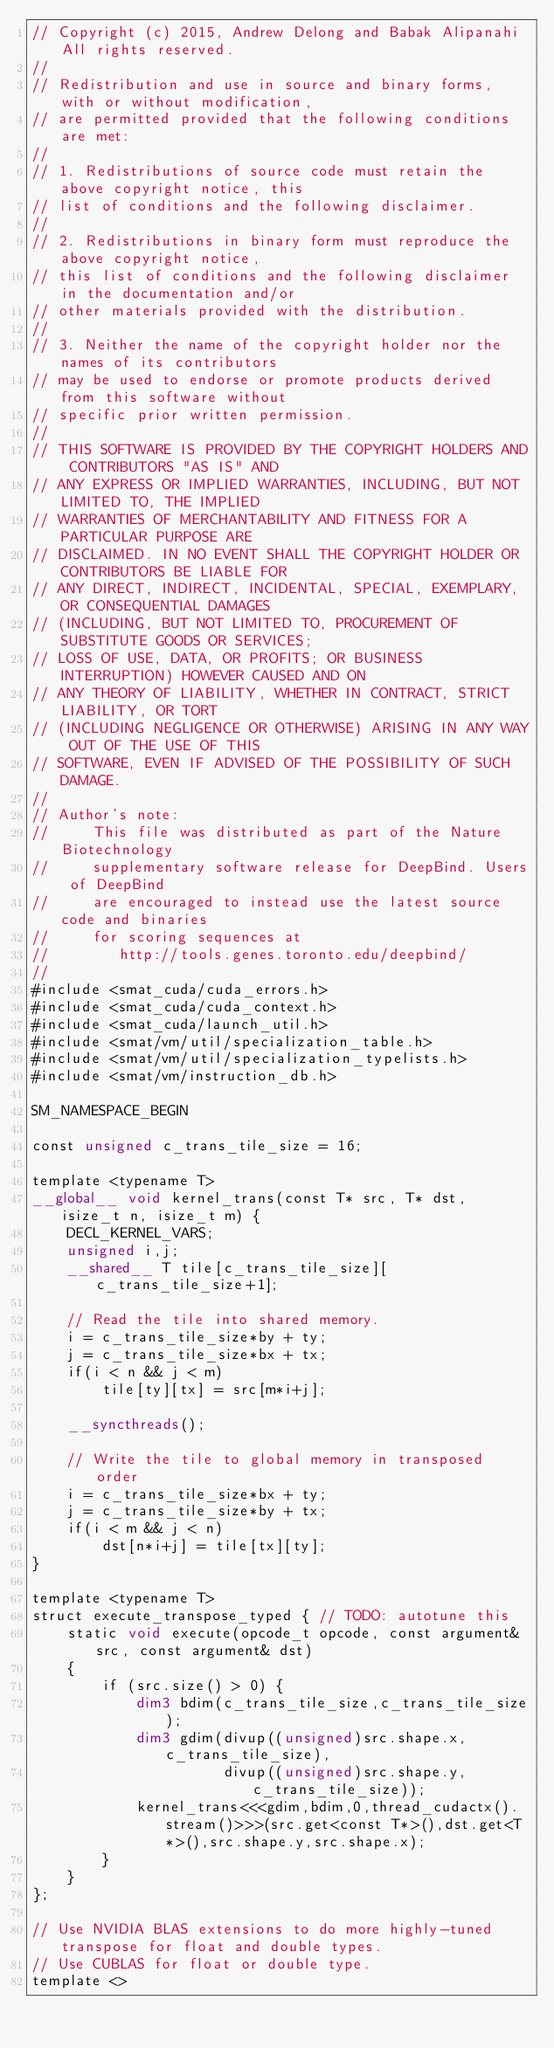Convert code to text. <code><loc_0><loc_0><loc_500><loc_500><_Cuda_>// Copyright (c) 2015, Andrew Delong and Babak Alipanahi All rights reserved.
// 
// Redistribution and use in source and binary forms, with or without modification,
// are permitted provided that the following conditions are met:
// 
// 1. Redistributions of source code must retain the above copyright notice, this
// list of conditions and the following disclaimer.
// 
// 2. Redistributions in binary form must reproduce the above copyright notice,
// this list of conditions and the following disclaimer in the documentation and/or
// other materials provided with the distribution.
// 
// 3. Neither the name of the copyright holder nor the names of its contributors
// may be used to endorse or promote products derived from this software without
// specific prior written permission.
// 
// THIS SOFTWARE IS PROVIDED BY THE COPYRIGHT HOLDERS AND CONTRIBUTORS "AS IS" AND
// ANY EXPRESS OR IMPLIED WARRANTIES, INCLUDING, BUT NOT LIMITED TO, THE IMPLIED
// WARRANTIES OF MERCHANTABILITY AND FITNESS FOR A PARTICULAR PURPOSE ARE
// DISCLAIMED. IN NO EVENT SHALL THE COPYRIGHT HOLDER OR CONTRIBUTORS BE LIABLE FOR
// ANY DIRECT, INDIRECT, INCIDENTAL, SPECIAL, EXEMPLARY, OR CONSEQUENTIAL DAMAGES
// (INCLUDING, BUT NOT LIMITED TO, PROCUREMENT OF SUBSTITUTE GOODS OR SERVICES;
// LOSS OF USE, DATA, OR PROFITS; OR BUSINESS INTERRUPTION) HOWEVER CAUSED AND ON
// ANY THEORY OF LIABILITY, WHETHER IN CONTRACT, STRICT LIABILITY, OR TORT
// (INCLUDING NEGLIGENCE OR OTHERWISE) ARISING IN ANY WAY OUT OF THE USE OF THIS
// SOFTWARE, EVEN IF ADVISED OF THE POSSIBILITY OF SUCH DAMAGE.
// 
// Author's note: 
//     This file was distributed as part of the Nature Biotechnology 
//     supplementary software release for DeepBind. Users of DeepBind
//     are encouraged to instead use the latest source code and binaries 
//     for scoring sequences at
//        http://tools.genes.toronto.edu/deepbind/
// 
#include <smat_cuda/cuda_errors.h>
#include <smat_cuda/cuda_context.h>
#include <smat_cuda/launch_util.h>
#include <smat/vm/util/specialization_table.h>
#include <smat/vm/util/specialization_typelists.h>
#include <smat/vm/instruction_db.h>

SM_NAMESPACE_BEGIN

const unsigned c_trans_tile_size = 16;

template <typename T> 
__global__ void kernel_trans(const T* src, T* dst, isize_t n, isize_t m) {
	DECL_KERNEL_VARS;
	unsigned i,j;
	__shared__ T tile[c_trans_tile_size][c_trans_tile_size+1];

	// Read the tile into shared memory.
	i = c_trans_tile_size*by + ty;
	j = c_trans_tile_size*bx + tx;
	if(i < n && j < m)
		tile[ty][tx] = src[m*i+j];

	__syncthreads();

	// Write the tile to global memory in transposed order
	i = c_trans_tile_size*bx + ty;
	j = c_trans_tile_size*by + tx;
	if(i < m && j < n)
		dst[n*i+j] = tile[tx][ty];
}

template <typename T>
struct execute_transpose_typed { // TODO: autotune this
	static void execute(opcode_t opcode, const argument& src, const argument& dst)
	{
		if (src.size() > 0) {
			dim3 bdim(c_trans_tile_size,c_trans_tile_size);
			dim3 gdim(divup((unsigned)src.shape.x,c_trans_tile_size),
					  divup((unsigned)src.shape.y,c_trans_tile_size));
			kernel_trans<<<gdim,bdim,0,thread_cudactx().stream()>>>(src.get<const T*>(),dst.get<T*>(),src.shape.y,src.shape.x);
		}
	}
};

// Use NVIDIA BLAS extensions to do more highly-tuned transpose for float and double types.
// Use CUBLAS for float or double type.
template <></code> 